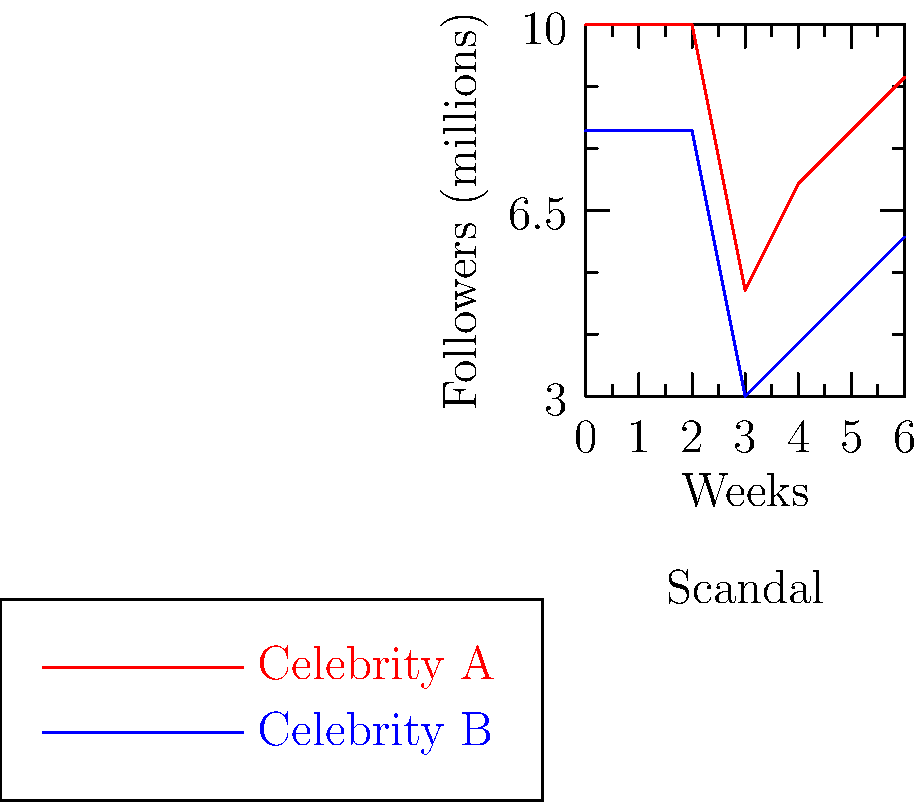In the chart above, two celebrities experience a scandal in week 3. Which celebrity's follower count recovers more quickly, and what industry strategy does this reflect? 1. Analyze the graph:
   - Both celebrities start with stable follower counts
   - At week 3, both experience a sharp drop (scandal occurs)
   - After week 3, both start to recover

2. Compare recovery rates:
   - Celebrity A (red line) drops from 10M to 5M, then recovers to 9M by week 6
   - Celebrity B (blue line) drops from 8M to 3M, then recovers to 6M by week 6

3. Calculate recovery percentages:
   - Celebrity A: $(9-5)/(10-5) \times 100\% = 80\%$ recovery
   - Celebrity B: $(6-3)/(8-3) \times 100\% = 60\%$ recovery

4. Industry strategy reflection:
   - Faster recovery (Celebrity A) suggests a "move on" approach
   - This aligns with the Hollywood insider perspective of not believing in public apologies

5. Conclusion:
   Celebrity A recovers more quickly, reflecting the industry strategy of minimizing scandal impact without public apology.
Answer: Celebrity A; "move on" without public apology 